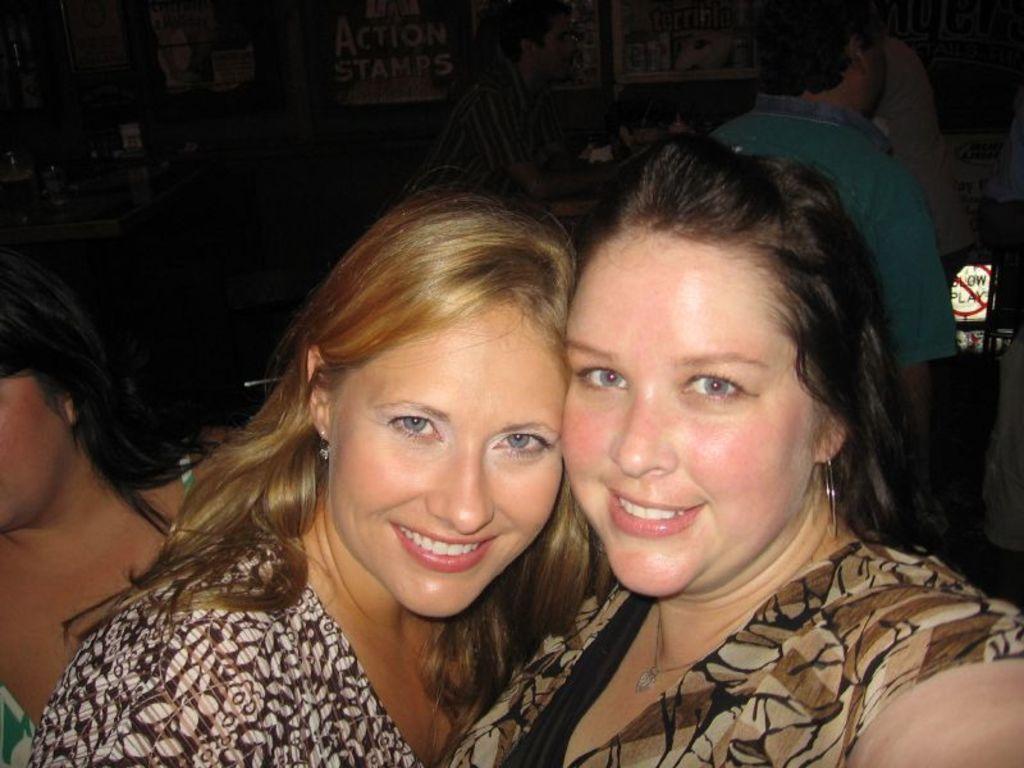In one or two sentences, can you explain what this image depicts? In this image I can see few people with different color dresses. In the background I can see the boards and something is written on it. 